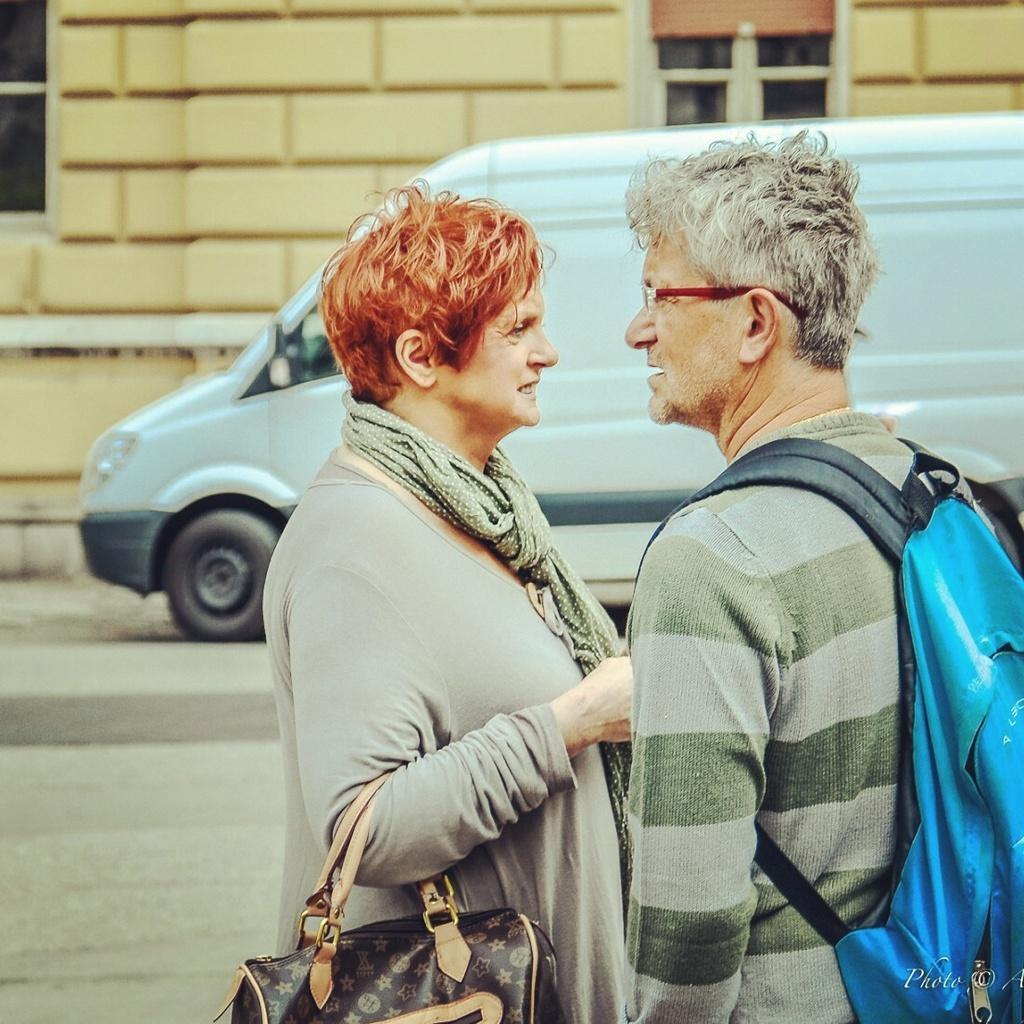Describe this image in one or two sentences. In this picture we can observe a couple. There is a man wearing spectacles and a bag on his shoulders which is in blue color. We can observe a woman. There is a scarf around her neck. She is holding a bag. In the background there is a vehicle. We can observe a yellow color wall and a window here. 